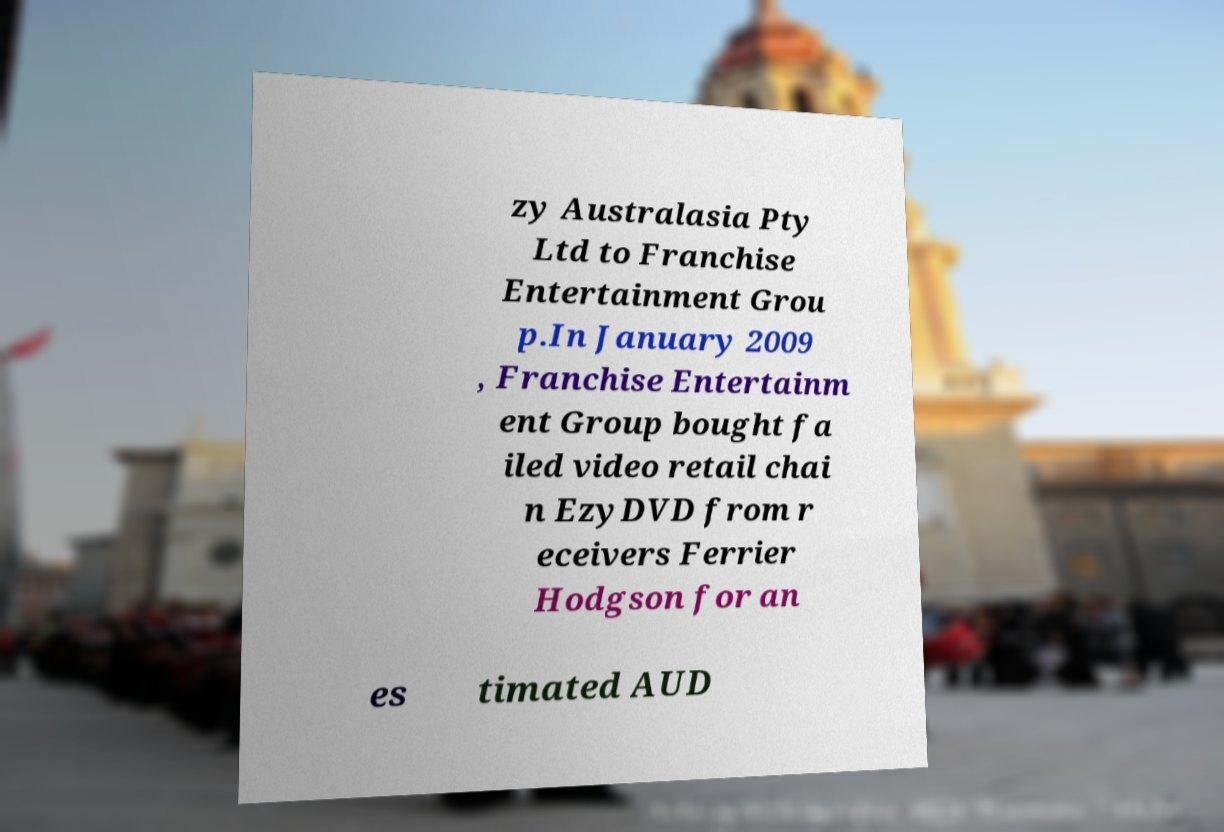I need the written content from this picture converted into text. Can you do that? zy Australasia Pty Ltd to Franchise Entertainment Grou p.In January 2009 , Franchise Entertainm ent Group bought fa iled video retail chai n EzyDVD from r eceivers Ferrier Hodgson for an es timated AUD 